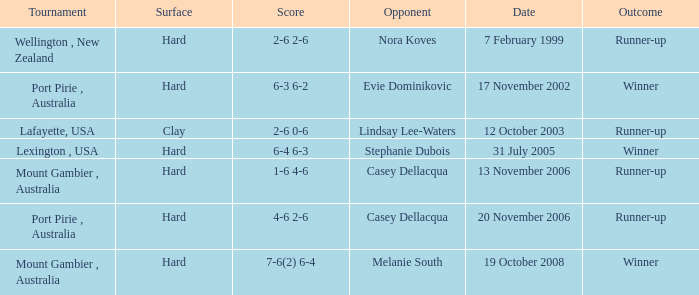Which Score has an Opponent of melanie south? 7-6(2) 6-4. 